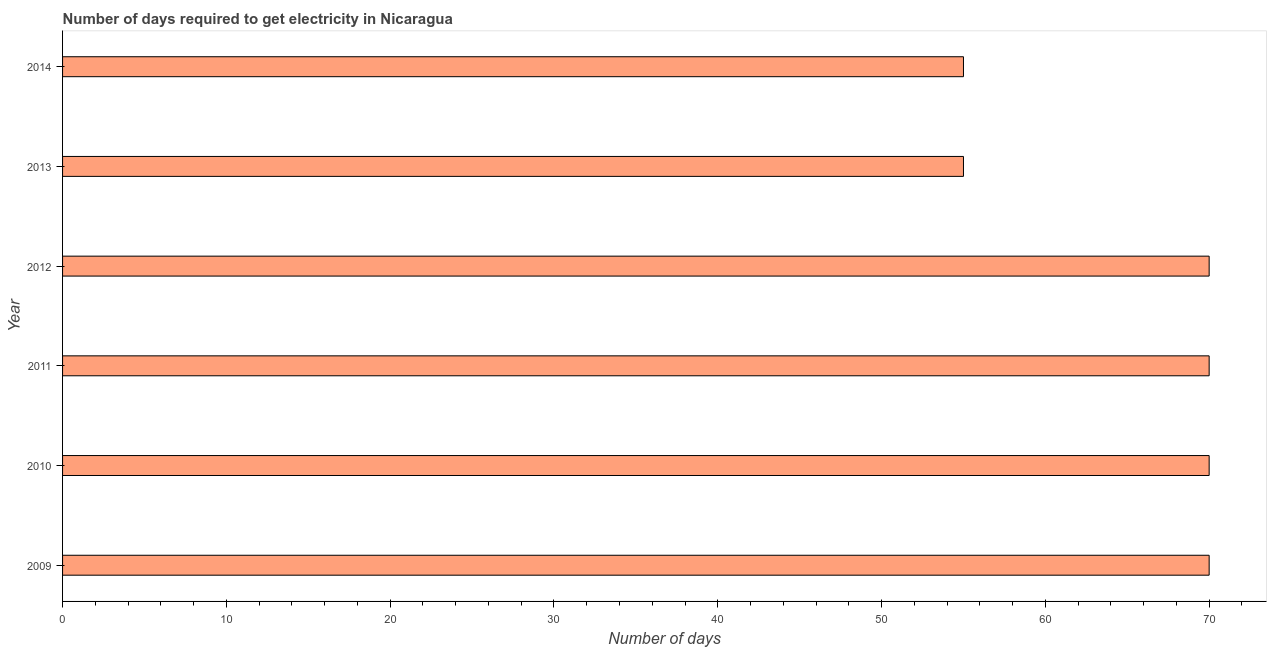Does the graph contain grids?
Your answer should be compact. No. What is the title of the graph?
Provide a succinct answer. Number of days required to get electricity in Nicaragua. What is the label or title of the X-axis?
Provide a succinct answer. Number of days. What is the label or title of the Y-axis?
Your response must be concise. Year. In which year was the time to get electricity maximum?
Offer a very short reply. 2009. What is the sum of the time to get electricity?
Provide a succinct answer. 390. What is the difference between the time to get electricity in 2010 and 2012?
Your answer should be very brief. 0. In how many years, is the time to get electricity greater than 56 ?
Make the answer very short. 4. What is the ratio of the time to get electricity in 2011 to that in 2013?
Keep it short and to the point. 1.27. Is the time to get electricity in 2011 less than that in 2013?
Provide a succinct answer. No. Is the difference between the time to get electricity in 2009 and 2013 greater than the difference between any two years?
Offer a very short reply. Yes. What is the difference between the highest and the second highest time to get electricity?
Provide a succinct answer. 0. What is the difference between the highest and the lowest time to get electricity?
Offer a very short reply. 15. In how many years, is the time to get electricity greater than the average time to get electricity taken over all years?
Your answer should be very brief. 4. Are all the bars in the graph horizontal?
Your answer should be very brief. Yes. What is the difference between two consecutive major ticks on the X-axis?
Offer a terse response. 10. What is the Number of days in 2009?
Your response must be concise. 70. What is the Number of days in 2010?
Make the answer very short. 70. What is the Number of days of 2011?
Offer a very short reply. 70. What is the Number of days of 2013?
Your response must be concise. 55. What is the Number of days in 2014?
Your answer should be very brief. 55. What is the difference between the Number of days in 2009 and 2013?
Provide a short and direct response. 15. What is the difference between the Number of days in 2009 and 2014?
Keep it short and to the point. 15. What is the difference between the Number of days in 2010 and 2011?
Make the answer very short. 0. What is the difference between the Number of days in 2010 and 2012?
Your response must be concise. 0. What is the difference between the Number of days in 2011 and 2012?
Provide a short and direct response. 0. What is the difference between the Number of days in 2011 and 2014?
Provide a short and direct response. 15. What is the difference between the Number of days in 2012 and 2013?
Provide a succinct answer. 15. What is the difference between the Number of days in 2012 and 2014?
Offer a very short reply. 15. What is the difference between the Number of days in 2013 and 2014?
Your response must be concise. 0. What is the ratio of the Number of days in 2009 to that in 2011?
Keep it short and to the point. 1. What is the ratio of the Number of days in 2009 to that in 2012?
Provide a succinct answer. 1. What is the ratio of the Number of days in 2009 to that in 2013?
Give a very brief answer. 1.27. What is the ratio of the Number of days in 2009 to that in 2014?
Keep it short and to the point. 1.27. What is the ratio of the Number of days in 2010 to that in 2013?
Offer a terse response. 1.27. What is the ratio of the Number of days in 2010 to that in 2014?
Provide a succinct answer. 1.27. What is the ratio of the Number of days in 2011 to that in 2012?
Make the answer very short. 1. What is the ratio of the Number of days in 2011 to that in 2013?
Your answer should be compact. 1.27. What is the ratio of the Number of days in 2011 to that in 2014?
Your answer should be compact. 1.27. What is the ratio of the Number of days in 2012 to that in 2013?
Your answer should be very brief. 1.27. What is the ratio of the Number of days in 2012 to that in 2014?
Make the answer very short. 1.27. 